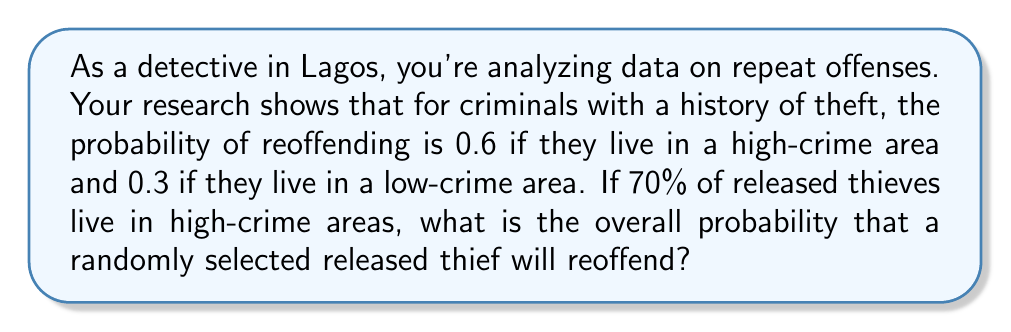Can you solve this math problem? Let's approach this step-by-step using the law of total probability:

1) Define events:
   A: The thief reoffends
   H: The thief lives in a high-crime area
   L: The thief lives in a low-crime area

2) Given probabilities:
   P(A|H) = 0.6 (probability of reoffending given high-crime area)
   P(A|L) = 0.3 (probability of reoffending given low-crime area)
   P(H) = 0.7 (probability of living in high-crime area)
   P(L) = 1 - P(H) = 0.3 (probability of living in low-crime area)

3) Law of Total Probability:
   P(A) = P(A|H) * P(H) + P(A|L) * P(L)

4) Substitute the values:
   P(A) = 0.6 * 0.7 + 0.3 * 0.3

5) Calculate:
   P(A) = 0.42 + 0.09 = 0.51

Therefore, the overall probability that a randomly selected released thief will reoffend is 0.51 or 51%.
Answer: The overall probability that a randomly selected released thief will reoffend is 0.51 or 51%. 